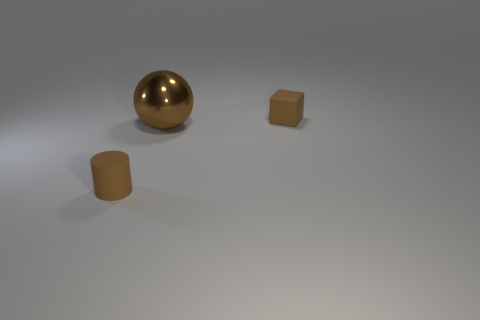How many small objects are brown rubber cylinders or blue cubes?
Offer a terse response. 1. Is the object that is in front of the big sphere made of the same material as the tiny object to the right of the brown cylinder?
Your answer should be compact. Yes. What is the material of the big sphere that is to the left of the small matte cube?
Offer a terse response. Metal. How many shiny objects are small blocks or big brown things?
Give a very brief answer. 1. There is a matte thing in front of the brown matte thing that is behind the big sphere; what is its color?
Your answer should be very brief. Brown. Are the block and the tiny brown thing that is to the left of the block made of the same material?
Provide a short and direct response. Yes. What is the color of the rubber object right of the small brown rubber thing to the left of the thing that is to the right of the brown shiny ball?
Offer a very short reply. Brown. Is there anything else that has the same shape as the shiny thing?
Offer a terse response. No. Are there more brown matte blocks than blue matte cubes?
Ensure brevity in your answer.  Yes. How many objects are both left of the tiny block and behind the small brown cylinder?
Your answer should be very brief. 1. 